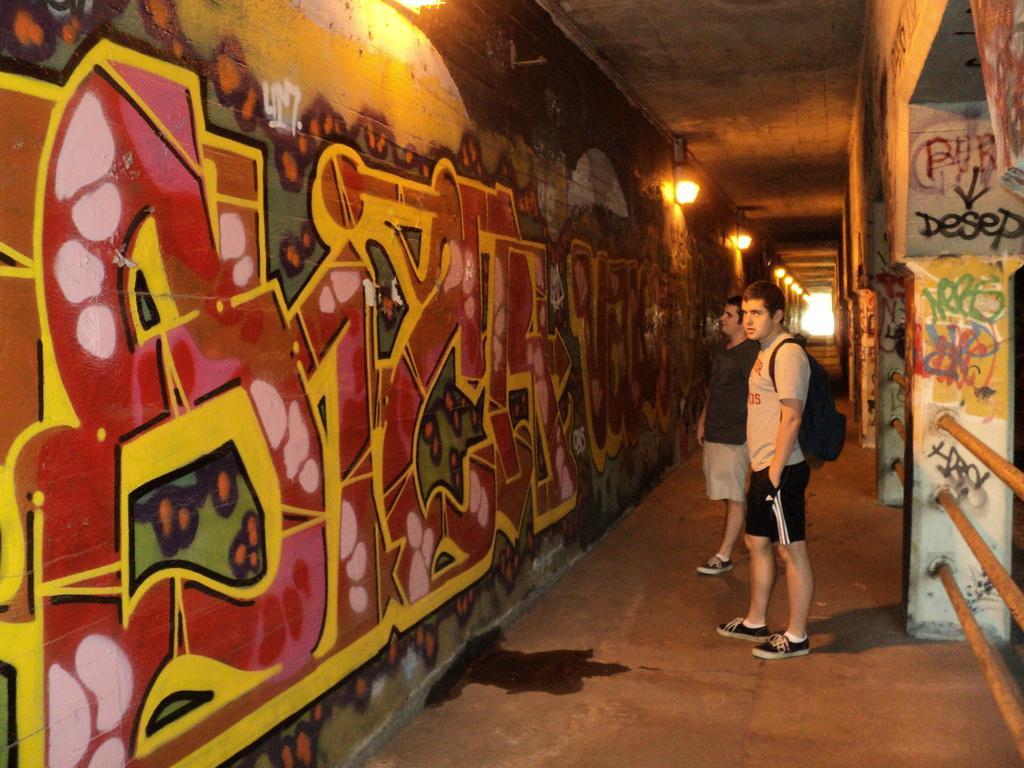How would you summarize this image in a sentence or two? In this picture there is a view of the tunnel. In the front there are two boys standing and looking straight. In the front there is a wall with spray paint and some spotlights. On the right side there is a yellow color railing. 